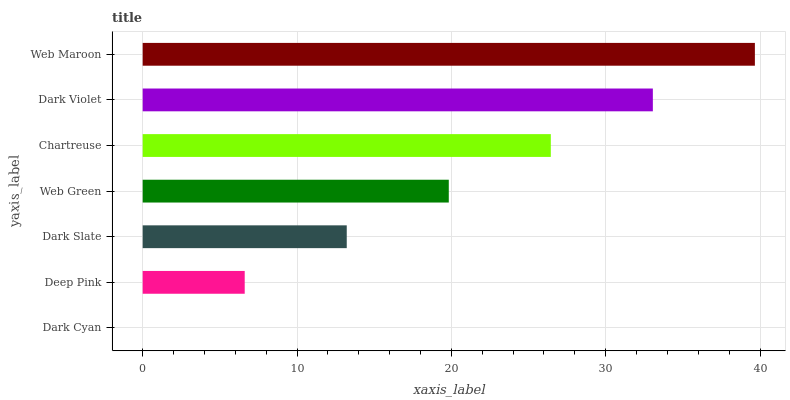Is Dark Cyan the minimum?
Answer yes or no. Yes. Is Web Maroon the maximum?
Answer yes or no. Yes. Is Deep Pink the minimum?
Answer yes or no. No. Is Deep Pink the maximum?
Answer yes or no. No. Is Deep Pink greater than Dark Cyan?
Answer yes or no. Yes. Is Dark Cyan less than Deep Pink?
Answer yes or no. Yes. Is Dark Cyan greater than Deep Pink?
Answer yes or no. No. Is Deep Pink less than Dark Cyan?
Answer yes or no. No. Is Web Green the high median?
Answer yes or no. Yes. Is Web Green the low median?
Answer yes or no. Yes. Is Deep Pink the high median?
Answer yes or no. No. Is Web Maroon the low median?
Answer yes or no. No. 